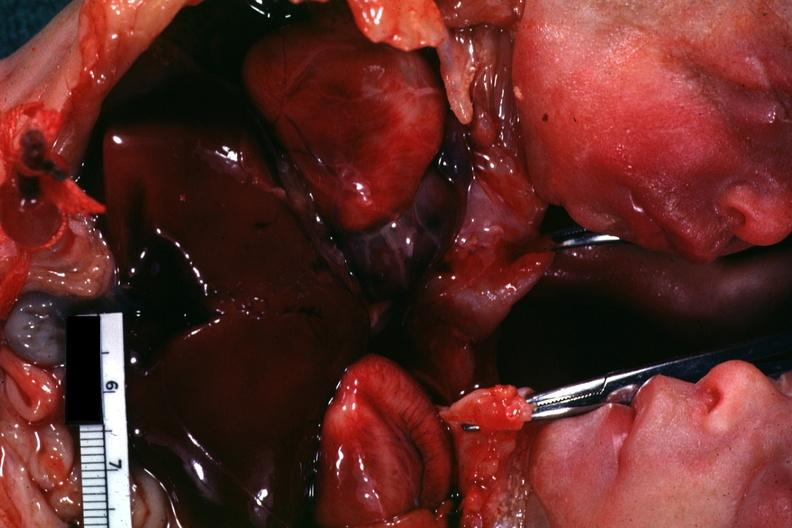how many hearts is this joined chest and abdomen slide shows opened chest with?
Answer the question using a single word or phrase. Two 